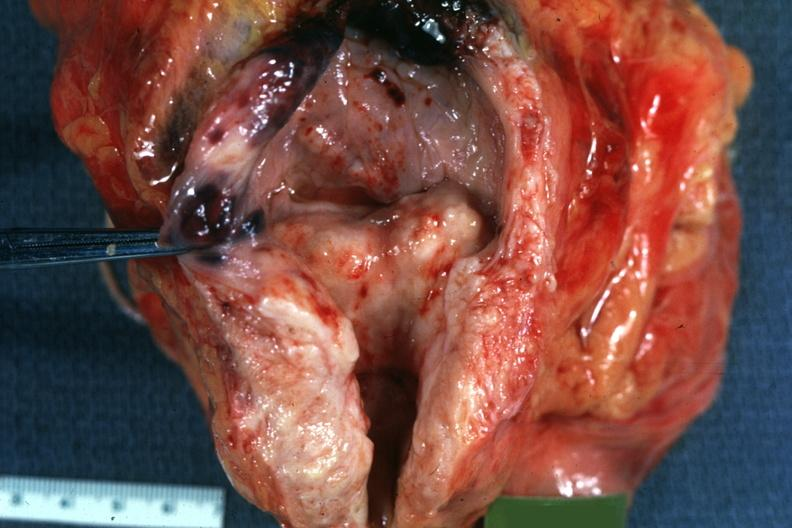does this image show median bar bladder hypertrophy good?
Answer the question using a single word or phrase. Yes 